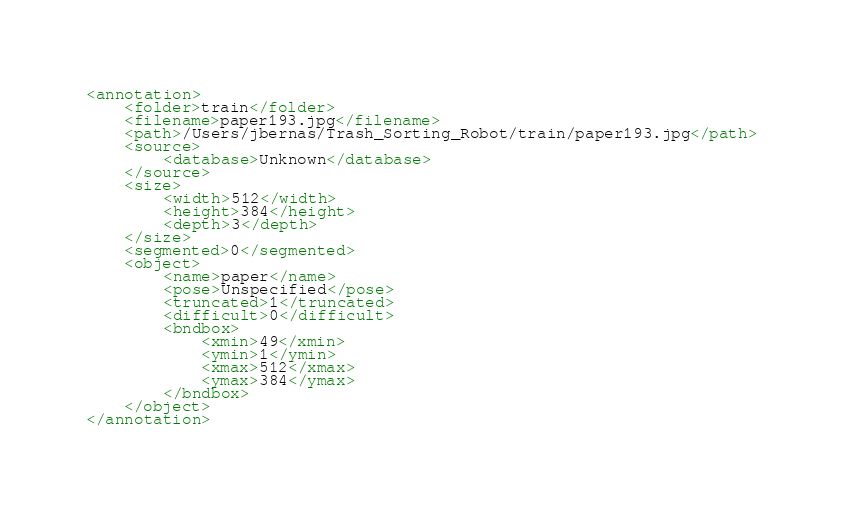<code> <loc_0><loc_0><loc_500><loc_500><_XML_><annotation>
	<folder>train</folder>
	<filename>paper193.jpg</filename>
	<path>/Users/jbernas/Trash_Sorting_Robot/train/paper193.jpg</path>
	<source>
		<database>Unknown</database>
	</source>
	<size>
		<width>512</width>
		<height>384</height>
		<depth>3</depth>
	</size>
	<segmented>0</segmented>
	<object>
		<name>paper</name>
		<pose>Unspecified</pose>
		<truncated>1</truncated>
		<difficult>0</difficult>
		<bndbox>
			<xmin>49</xmin>
			<ymin>1</ymin>
			<xmax>512</xmax>
			<ymax>384</ymax>
		</bndbox>
	</object>
</annotation>
</code> 